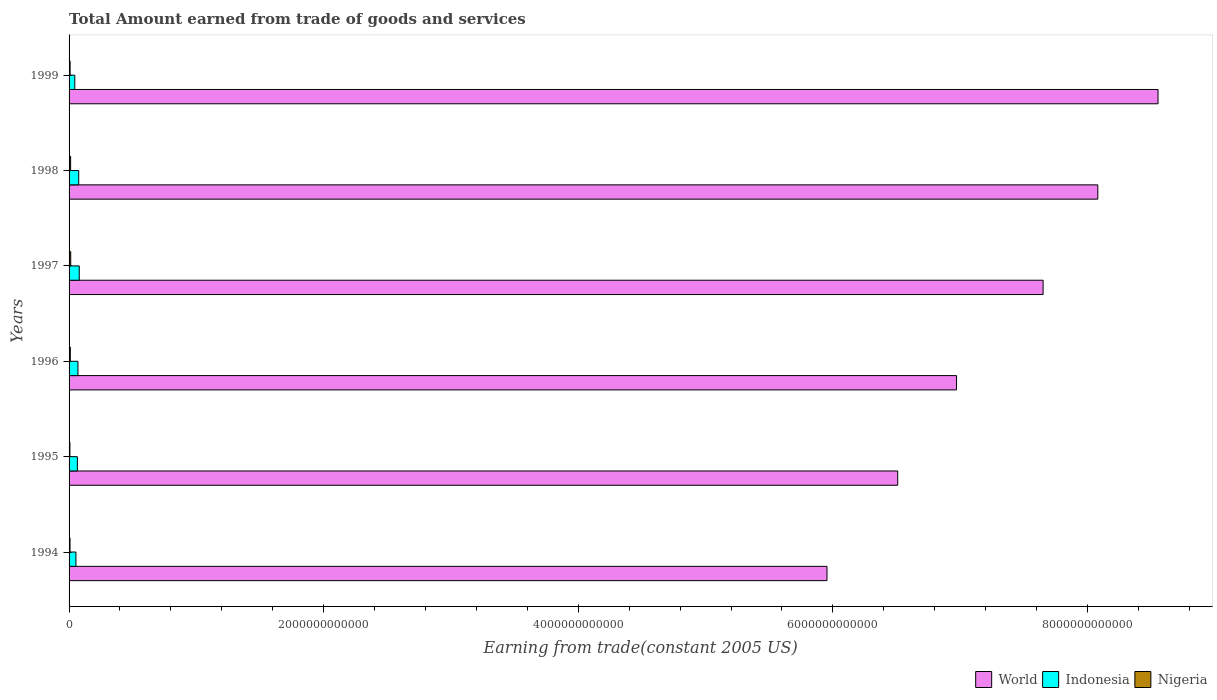How many different coloured bars are there?
Your answer should be compact. 3. How many groups of bars are there?
Offer a terse response. 6. How many bars are there on the 6th tick from the top?
Your answer should be very brief. 3. How many bars are there on the 1st tick from the bottom?
Keep it short and to the point. 3. What is the total amount earned by trading goods and services in Indonesia in 1996?
Your answer should be compact. 6.97e+1. Across all years, what is the maximum total amount earned by trading goods and services in World?
Provide a short and direct response. 8.55e+12. Across all years, what is the minimum total amount earned by trading goods and services in Nigeria?
Give a very brief answer. 6.54e+09. In which year was the total amount earned by trading goods and services in World maximum?
Provide a short and direct response. 1999. In which year was the total amount earned by trading goods and services in Nigeria minimum?
Keep it short and to the point. 1995. What is the total total amount earned by trading goods and services in Indonesia in the graph?
Give a very brief answer. 3.90e+11. What is the difference between the total amount earned by trading goods and services in Indonesia in 1995 and that in 1997?
Keep it short and to the point. -1.47e+1. What is the difference between the total amount earned by trading goods and services in World in 1995 and the total amount earned by trading goods and services in Nigeria in 1999?
Keep it short and to the point. 6.50e+12. What is the average total amount earned by trading goods and services in Indonesia per year?
Your answer should be compact. 6.49e+1. In the year 1996, what is the difference between the total amount earned by trading goods and services in Indonesia and total amount earned by trading goods and services in World?
Offer a very short reply. -6.90e+12. What is the ratio of the total amount earned by trading goods and services in World in 1998 to that in 1999?
Offer a terse response. 0.94. Is the total amount earned by trading goods and services in World in 1994 less than that in 1999?
Offer a terse response. Yes. Is the difference between the total amount earned by trading goods and services in Indonesia in 1996 and 1997 greater than the difference between the total amount earned by trading goods and services in World in 1996 and 1997?
Provide a short and direct response. Yes. What is the difference between the highest and the second highest total amount earned by trading goods and services in World?
Keep it short and to the point. 4.73e+11. What is the difference between the highest and the lowest total amount earned by trading goods and services in Indonesia?
Give a very brief answer. 3.50e+1. In how many years, is the total amount earned by trading goods and services in Indonesia greater than the average total amount earned by trading goods and services in Indonesia taken over all years?
Give a very brief answer. 4. Is the sum of the total amount earned by trading goods and services in Indonesia in 1995 and 1996 greater than the maximum total amount earned by trading goods and services in World across all years?
Your response must be concise. No. What does the 2nd bar from the top in 1995 represents?
Ensure brevity in your answer.  Indonesia. What does the 1st bar from the bottom in 1994 represents?
Give a very brief answer. World. How many bars are there?
Offer a terse response. 18. What is the difference between two consecutive major ticks on the X-axis?
Offer a terse response. 2.00e+12. Are the values on the major ticks of X-axis written in scientific E-notation?
Make the answer very short. No. Does the graph contain any zero values?
Make the answer very short. No. Does the graph contain grids?
Provide a short and direct response. No. How many legend labels are there?
Your answer should be compact. 3. What is the title of the graph?
Offer a terse response. Total Amount earned from trade of goods and services. Does "Rwanda" appear as one of the legend labels in the graph?
Your answer should be compact. No. What is the label or title of the X-axis?
Your answer should be very brief. Earning from trade(constant 2005 US). What is the Earning from trade(constant 2005 US) in World in 1994?
Give a very brief answer. 5.95e+12. What is the Earning from trade(constant 2005 US) in Indonesia in 1994?
Give a very brief answer. 5.40e+1. What is the Earning from trade(constant 2005 US) in Nigeria in 1994?
Provide a short and direct response. 7.42e+09. What is the Earning from trade(constant 2005 US) in World in 1995?
Provide a succinct answer. 6.51e+12. What is the Earning from trade(constant 2005 US) of Indonesia in 1995?
Provide a succinct answer. 6.53e+1. What is the Earning from trade(constant 2005 US) in Nigeria in 1995?
Your answer should be compact. 6.54e+09. What is the Earning from trade(constant 2005 US) in World in 1996?
Provide a succinct answer. 6.97e+12. What is the Earning from trade(constant 2005 US) of Indonesia in 1996?
Give a very brief answer. 6.97e+1. What is the Earning from trade(constant 2005 US) in Nigeria in 1996?
Offer a terse response. 9.72e+09. What is the Earning from trade(constant 2005 US) of World in 1997?
Give a very brief answer. 7.65e+12. What is the Earning from trade(constant 2005 US) in Indonesia in 1997?
Your answer should be compact. 8.00e+1. What is the Earning from trade(constant 2005 US) in Nigeria in 1997?
Keep it short and to the point. 1.31e+1. What is the Earning from trade(constant 2005 US) of World in 1998?
Ensure brevity in your answer.  8.08e+12. What is the Earning from trade(constant 2005 US) in Indonesia in 1998?
Offer a very short reply. 7.58e+1. What is the Earning from trade(constant 2005 US) in Nigeria in 1998?
Provide a short and direct response. 1.23e+1. What is the Earning from trade(constant 2005 US) in World in 1999?
Your answer should be compact. 8.55e+12. What is the Earning from trade(constant 2005 US) of Indonesia in 1999?
Your answer should be compact. 4.49e+1. What is the Earning from trade(constant 2005 US) in Nigeria in 1999?
Your answer should be very brief. 8.12e+09. Across all years, what is the maximum Earning from trade(constant 2005 US) of World?
Keep it short and to the point. 8.55e+12. Across all years, what is the maximum Earning from trade(constant 2005 US) of Indonesia?
Your answer should be compact. 8.00e+1. Across all years, what is the maximum Earning from trade(constant 2005 US) in Nigeria?
Ensure brevity in your answer.  1.31e+1. Across all years, what is the minimum Earning from trade(constant 2005 US) in World?
Provide a short and direct response. 5.95e+12. Across all years, what is the minimum Earning from trade(constant 2005 US) in Indonesia?
Give a very brief answer. 4.49e+1. Across all years, what is the minimum Earning from trade(constant 2005 US) in Nigeria?
Offer a very short reply. 6.54e+09. What is the total Earning from trade(constant 2005 US) in World in the graph?
Make the answer very short. 4.37e+13. What is the total Earning from trade(constant 2005 US) of Indonesia in the graph?
Your response must be concise. 3.90e+11. What is the total Earning from trade(constant 2005 US) of Nigeria in the graph?
Offer a terse response. 5.72e+1. What is the difference between the Earning from trade(constant 2005 US) in World in 1994 and that in 1995?
Provide a succinct answer. -5.55e+11. What is the difference between the Earning from trade(constant 2005 US) of Indonesia in 1994 and that in 1995?
Give a very brief answer. -1.13e+1. What is the difference between the Earning from trade(constant 2005 US) in Nigeria in 1994 and that in 1995?
Keep it short and to the point. 8.81e+08. What is the difference between the Earning from trade(constant 2005 US) in World in 1994 and that in 1996?
Your answer should be compact. -1.02e+12. What is the difference between the Earning from trade(constant 2005 US) of Indonesia in 1994 and that in 1996?
Your response must be concise. -1.58e+1. What is the difference between the Earning from trade(constant 2005 US) of Nigeria in 1994 and that in 1996?
Give a very brief answer. -2.31e+09. What is the difference between the Earning from trade(constant 2005 US) of World in 1994 and that in 1997?
Provide a succinct answer. -1.70e+12. What is the difference between the Earning from trade(constant 2005 US) of Indonesia in 1994 and that in 1997?
Offer a terse response. -2.60e+1. What is the difference between the Earning from trade(constant 2005 US) of Nigeria in 1994 and that in 1997?
Offer a very short reply. -5.70e+09. What is the difference between the Earning from trade(constant 2005 US) in World in 1994 and that in 1998?
Make the answer very short. -2.13e+12. What is the difference between the Earning from trade(constant 2005 US) of Indonesia in 1994 and that in 1998?
Ensure brevity in your answer.  -2.18e+1. What is the difference between the Earning from trade(constant 2005 US) in Nigeria in 1994 and that in 1998?
Offer a very short reply. -4.84e+09. What is the difference between the Earning from trade(constant 2005 US) in World in 1994 and that in 1999?
Make the answer very short. -2.60e+12. What is the difference between the Earning from trade(constant 2005 US) of Indonesia in 1994 and that in 1999?
Provide a short and direct response. 9.01e+09. What is the difference between the Earning from trade(constant 2005 US) of Nigeria in 1994 and that in 1999?
Keep it short and to the point. -7.09e+08. What is the difference between the Earning from trade(constant 2005 US) of World in 1995 and that in 1996?
Make the answer very short. -4.62e+11. What is the difference between the Earning from trade(constant 2005 US) in Indonesia in 1995 and that in 1996?
Your answer should be compact. -4.48e+09. What is the difference between the Earning from trade(constant 2005 US) of Nigeria in 1995 and that in 1996?
Make the answer very short. -3.19e+09. What is the difference between the Earning from trade(constant 2005 US) in World in 1995 and that in 1997?
Your response must be concise. -1.14e+12. What is the difference between the Earning from trade(constant 2005 US) in Indonesia in 1995 and that in 1997?
Make the answer very short. -1.47e+1. What is the difference between the Earning from trade(constant 2005 US) of Nigeria in 1995 and that in 1997?
Provide a succinct answer. -6.58e+09. What is the difference between the Earning from trade(constant 2005 US) in World in 1995 and that in 1998?
Offer a very short reply. -1.57e+12. What is the difference between the Earning from trade(constant 2005 US) of Indonesia in 1995 and that in 1998?
Offer a very short reply. -1.05e+1. What is the difference between the Earning from trade(constant 2005 US) in Nigeria in 1995 and that in 1998?
Your answer should be very brief. -5.72e+09. What is the difference between the Earning from trade(constant 2005 US) of World in 1995 and that in 1999?
Offer a terse response. -2.05e+12. What is the difference between the Earning from trade(constant 2005 US) of Indonesia in 1995 and that in 1999?
Your answer should be very brief. 2.03e+1. What is the difference between the Earning from trade(constant 2005 US) in Nigeria in 1995 and that in 1999?
Provide a short and direct response. -1.59e+09. What is the difference between the Earning from trade(constant 2005 US) of World in 1996 and that in 1997?
Provide a succinct answer. -6.80e+11. What is the difference between the Earning from trade(constant 2005 US) in Indonesia in 1996 and that in 1997?
Your answer should be very brief. -1.03e+1. What is the difference between the Earning from trade(constant 2005 US) of Nigeria in 1996 and that in 1997?
Give a very brief answer. -3.39e+09. What is the difference between the Earning from trade(constant 2005 US) in World in 1996 and that in 1998?
Ensure brevity in your answer.  -1.11e+12. What is the difference between the Earning from trade(constant 2005 US) of Indonesia in 1996 and that in 1998?
Your response must be concise. -6.03e+09. What is the difference between the Earning from trade(constant 2005 US) of Nigeria in 1996 and that in 1998?
Your response must be concise. -2.53e+09. What is the difference between the Earning from trade(constant 2005 US) of World in 1996 and that in 1999?
Your response must be concise. -1.58e+12. What is the difference between the Earning from trade(constant 2005 US) in Indonesia in 1996 and that in 1999?
Keep it short and to the point. 2.48e+1. What is the difference between the Earning from trade(constant 2005 US) in Nigeria in 1996 and that in 1999?
Provide a succinct answer. 1.60e+09. What is the difference between the Earning from trade(constant 2005 US) in World in 1997 and that in 1998?
Your answer should be compact. -4.30e+11. What is the difference between the Earning from trade(constant 2005 US) of Indonesia in 1997 and that in 1998?
Make the answer very short. 4.23e+09. What is the difference between the Earning from trade(constant 2005 US) of Nigeria in 1997 and that in 1998?
Provide a short and direct response. 8.57e+08. What is the difference between the Earning from trade(constant 2005 US) of World in 1997 and that in 1999?
Offer a terse response. -9.03e+11. What is the difference between the Earning from trade(constant 2005 US) in Indonesia in 1997 and that in 1999?
Provide a short and direct response. 3.50e+1. What is the difference between the Earning from trade(constant 2005 US) in Nigeria in 1997 and that in 1999?
Your response must be concise. 4.99e+09. What is the difference between the Earning from trade(constant 2005 US) of World in 1998 and that in 1999?
Give a very brief answer. -4.73e+11. What is the difference between the Earning from trade(constant 2005 US) of Indonesia in 1998 and that in 1999?
Your answer should be compact. 3.08e+1. What is the difference between the Earning from trade(constant 2005 US) in Nigeria in 1998 and that in 1999?
Make the answer very short. 4.13e+09. What is the difference between the Earning from trade(constant 2005 US) in World in 1994 and the Earning from trade(constant 2005 US) in Indonesia in 1995?
Provide a succinct answer. 5.89e+12. What is the difference between the Earning from trade(constant 2005 US) in World in 1994 and the Earning from trade(constant 2005 US) in Nigeria in 1995?
Provide a succinct answer. 5.95e+12. What is the difference between the Earning from trade(constant 2005 US) in Indonesia in 1994 and the Earning from trade(constant 2005 US) in Nigeria in 1995?
Make the answer very short. 4.74e+1. What is the difference between the Earning from trade(constant 2005 US) in World in 1994 and the Earning from trade(constant 2005 US) in Indonesia in 1996?
Your answer should be very brief. 5.88e+12. What is the difference between the Earning from trade(constant 2005 US) in World in 1994 and the Earning from trade(constant 2005 US) in Nigeria in 1996?
Make the answer very short. 5.94e+12. What is the difference between the Earning from trade(constant 2005 US) in Indonesia in 1994 and the Earning from trade(constant 2005 US) in Nigeria in 1996?
Your answer should be very brief. 4.42e+1. What is the difference between the Earning from trade(constant 2005 US) in World in 1994 and the Earning from trade(constant 2005 US) in Indonesia in 1997?
Your answer should be compact. 5.87e+12. What is the difference between the Earning from trade(constant 2005 US) of World in 1994 and the Earning from trade(constant 2005 US) of Nigeria in 1997?
Ensure brevity in your answer.  5.94e+12. What is the difference between the Earning from trade(constant 2005 US) of Indonesia in 1994 and the Earning from trade(constant 2005 US) of Nigeria in 1997?
Your response must be concise. 4.08e+1. What is the difference between the Earning from trade(constant 2005 US) in World in 1994 and the Earning from trade(constant 2005 US) in Indonesia in 1998?
Offer a very short reply. 5.88e+12. What is the difference between the Earning from trade(constant 2005 US) in World in 1994 and the Earning from trade(constant 2005 US) in Nigeria in 1998?
Provide a short and direct response. 5.94e+12. What is the difference between the Earning from trade(constant 2005 US) in Indonesia in 1994 and the Earning from trade(constant 2005 US) in Nigeria in 1998?
Make the answer very short. 4.17e+1. What is the difference between the Earning from trade(constant 2005 US) in World in 1994 and the Earning from trade(constant 2005 US) in Indonesia in 1999?
Your answer should be compact. 5.91e+12. What is the difference between the Earning from trade(constant 2005 US) in World in 1994 and the Earning from trade(constant 2005 US) in Nigeria in 1999?
Your answer should be compact. 5.95e+12. What is the difference between the Earning from trade(constant 2005 US) of Indonesia in 1994 and the Earning from trade(constant 2005 US) of Nigeria in 1999?
Your response must be concise. 4.58e+1. What is the difference between the Earning from trade(constant 2005 US) of World in 1995 and the Earning from trade(constant 2005 US) of Indonesia in 1996?
Offer a terse response. 6.44e+12. What is the difference between the Earning from trade(constant 2005 US) of World in 1995 and the Earning from trade(constant 2005 US) of Nigeria in 1996?
Keep it short and to the point. 6.50e+12. What is the difference between the Earning from trade(constant 2005 US) in Indonesia in 1995 and the Earning from trade(constant 2005 US) in Nigeria in 1996?
Offer a very short reply. 5.55e+1. What is the difference between the Earning from trade(constant 2005 US) in World in 1995 and the Earning from trade(constant 2005 US) in Indonesia in 1997?
Give a very brief answer. 6.43e+12. What is the difference between the Earning from trade(constant 2005 US) of World in 1995 and the Earning from trade(constant 2005 US) of Nigeria in 1997?
Offer a very short reply. 6.50e+12. What is the difference between the Earning from trade(constant 2005 US) of Indonesia in 1995 and the Earning from trade(constant 2005 US) of Nigeria in 1997?
Ensure brevity in your answer.  5.21e+1. What is the difference between the Earning from trade(constant 2005 US) in World in 1995 and the Earning from trade(constant 2005 US) in Indonesia in 1998?
Your answer should be very brief. 6.43e+12. What is the difference between the Earning from trade(constant 2005 US) in World in 1995 and the Earning from trade(constant 2005 US) in Nigeria in 1998?
Keep it short and to the point. 6.50e+12. What is the difference between the Earning from trade(constant 2005 US) in Indonesia in 1995 and the Earning from trade(constant 2005 US) in Nigeria in 1998?
Offer a very short reply. 5.30e+1. What is the difference between the Earning from trade(constant 2005 US) of World in 1995 and the Earning from trade(constant 2005 US) of Indonesia in 1999?
Give a very brief answer. 6.46e+12. What is the difference between the Earning from trade(constant 2005 US) in World in 1995 and the Earning from trade(constant 2005 US) in Nigeria in 1999?
Provide a succinct answer. 6.50e+12. What is the difference between the Earning from trade(constant 2005 US) of Indonesia in 1995 and the Earning from trade(constant 2005 US) of Nigeria in 1999?
Ensure brevity in your answer.  5.71e+1. What is the difference between the Earning from trade(constant 2005 US) in World in 1996 and the Earning from trade(constant 2005 US) in Indonesia in 1997?
Keep it short and to the point. 6.89e+12. What is the difference between the Earning from trade(constant 2005 US) in World in 1996 and the Earning from trade(constant 2005 US) in Nigeria in 1997?
Provide a succinct answer. 6.96e+12. What is the difference between the Earning from trade(constant 2005 US) of Indonesia in 1996 and the Earning from trade(constant 2005 US) of Nigeria in 1997?
Your response must be concise. 5.66e+1. What is the difference between the Earning from trade(constant 2005 US) in World in 1996 and the Earning from trade(constant 2005 US) in Indonesia in 1998?
Provide a short and direct response. 6.90e+12. What is the difference between the Earning from trade(constant 2005 US) of World in 1996 and the Earning from trade(constant 2005 US) of Nigeria in 1998?
Provide a succinct answer. 6.96e+12. What is the difference between the Earning from trade(constant 2005 US) in Indonesia in 1996 and the Earning from trade(constant 2005 US) in Nigeria in 1998?
Keep it short and to the point. 5.75e+1. What is the difference between the Earning from trade(constant 2005 US) of World in 1996 and the Earning from trade(constant 2005 US) of Indonesia in 1999?
Your answer should be very brief. 6.93e+12. What is the difference between the Earning from trade(constant 2005 US) in World in 1996 and the Earning from trade(constant 2005 US) in Nigeria in 1999?
Offer a terse response. 6.96e+12. What is the difference between the Earning from trade(constant 2005 US) of Indonesia in 1996 and the Earning from trade(constant 2005 US) of Nigeria in 1999?
Ensure brevity in your answer.  6.16e+1. What is the difference between the Earning from trade(constant 2005 US) of World in 1997 and the Earning from trade(constant 2005 US) of Indonesia in 1998?
Your answer should be compact. 7.58e+12. What is the difference between the Earning from trade(constant 2005 US) in World in 1997 and the Earning from trade(constant 2005 US) in Nigeria in 1998?
Offer a very short reply. 7.64e+12. What is the difference between the Earning from trade(constant 2005 US) of Indonesia in 1997 and the Earning from trade(constant 2005 US) of Nigeria in 1998?
Provide a short and direct response. 6.77e+1. What is the difference between the Earning from trade(constant 2005 US) of World in 1997 and the Earning from trade(constant 2005 US) of Indonesia in 1999?
Offer a very short reply. 7.61e+12. What is the difference between the Earning from trade(constant 2005 US) of World in 1997 and the Earning from trade(constant 2005 US) of Nigeria in 1999?
Keep it short and to the point. 7.64e+12. What is the difference between the Earning from trade(constant 2005 US) of Indonesia in 1997 and the Earning from trade(constant 2005 US) of Nigeria in 1999?
Offer a terse response. 7.19e+1. What is the difference between the Earning from trade(constant 2005 US) in World in 1998 and the Earning from trade(constant 2005 US) in Indonesia in 1999?
Your answer should be very brief. 8.04e+12. What is the difference between the Earning from trade(constant 2005 US) of World in 1998 and the Earning from trade(constant 2005 US) of Nigeria in 1999?
Your answer should be compact. 8.07e+12. What is the difference between the Earning from trade(constant 2005 US) of Indonesia in 1998 and the Earning from trade(constant 2005 US) of Nigeria in 1999?
Ensure brevity in your answer.  6.76e+1. What is the average Earning from trade(constant 2005 US) in World per year?
Keep it short and to the point. 7.29e+12. What is the average Earning from trade(constant 2005 US) of Indonesia per year?
Provide a succinct answer. 6.49e+1. What is the average Earning from trade(constant 2005 US) of Nigeria per year?
Your response must be concise. 9.53e+09. In the year 1994, what is the difference between the Earning from trade(constant 2005 US) of World and Earning from trade(constant 2005 US) of Indonesia?
Provide a short and direct response. 5.90e+12. In the year 1994, what is the difference between the Earning from trade(constant 2005 US) of World and Earning from trade(constant 2005 US) of Nigeria?
Keep it short and to the point. 5.95e+12. In the year 1994, what is the difference between the Earning from trade(constant 2005 US) in Indonesia and Earning from trade(constant 2005 US) in Nigeria?
Provide a succinct answer. 4.65e+1. In the year 1995, what is the difference between the Earning from trade(constant 2005 US) of World and Earning from trade(constant 2005 US) of Indonesia?
Your response must be concise. 6.44e+12. In the year 1995, what is the difference between the Earning from trade(constant 2005 US) in World and Earning from trade(constant 2005 US) in Nigeria?
Keep it short and to the point. 6.50e+12. In the year 1995, what is the difference between the Earning from trade(constant 2005 US) of Indonesia and Earning from trade(constant 2005 US) of Nigeria?
Offer a very short reply. 5.87e+1. In the year 1996, what is the difference between the Earning from trade(constant 2005 US) in World and Earning from trade(constant 2005 US) in Indonesia?
Offer a terse response. 6.90e+12. In the year 1996, what is the difference between the Earning from trade(constant 2005 US) in World and Earning from trade(constant 2005 US) in Nigeria?
Provide a succinct answer. 6.96e+12. In the year 1996, what is the difference between the Earning from trade(constant 2005 US) of Indonesia and Earning from trade(constant 2005 US) of Nigeria?
Your response must be concise. 6.00e+1. In the year 1997, what is the difference between the Earning from trade(constant 2005 US) in World and Earning from trade(constant 2005 US) in Indonesia?
Keep it short and to the point. 7.57e+12. In the year 1997, what is the difference between the Earning from trade(constant 2005 US) in World and Earning from trade(constant 2005 US) in Nigeria?
Your answer should be compact. 7.64e+12. In the year 1997, what is the difference between the Earning from trade(constant 2005 US) of Indonesia and Earning from trade(constant 2005 US) of Nigeria?
Provide a short and direct response. 6.69e+1. In the year 1998, what is the difference between the Earning from trade(constant 2005 US) in World and Earning from trade(constant 2005 US) in Indonesia?
Keep it short and to the point. 8.01e+12. In the year 1998, what is the difference between the Earning from trade(constant 2005 US) in World and Earning from trade(constant 2005 US) in Nigeria?
Give a very brief answer. 8.07e+12. In the year 1998, what is the difference between the Earning from trade(constant 2005 US) of Indonesia and Earning from trade(constant 2005 US) of Nigeria?
Your answer should be compact. 6.35e+1. In the year 1999, what is the difference between the Earning from trade(constant 2005 US) in World and Earning from trade(constant 2005 US) in Indonesia?
Give a very brief answer. 8.51e+12. In the year 1999, what is the difference between the Earning from trade(constant 2005 US) of World and Earning from trade(constant 2005 US) of Nigeria?
Give a very brief answer. 8.55e+12. In the year 1999, what is the difference between the Earning from trade(constant 2005 US) in Indonesia and Earning from trade(constant 2005 US) in Nigeria?
Your answer should be compact. 3.68e+1. What is the ratio of the Earning from trade(constant 2005 US) in World in 1994 to that in 1995?
Ensure brevity in your answer.  0.91. What is the ratio of the Earning from trade(constant 2005 US) of Indonesia in 1994 to that in 1995?
Ensure brevity in your answer.  0.83. What is the ratio of the Earning from trade(constant 2005 US) in Nigeria in 1994 to that in 1995?
Your answer should be very brief. 1.13. What is the ratio of the Earning from trade(constant 2005 US) in World in 1994 to that in 1996?
Your answer should be compact. 0.85. What is the ratio of the Earning from trade(constant 2005 US) of Indonesia in 1994 to that in 1996?
Give a very brief answer. 0.77. What is the ratio of the Earning from trade(constant 2005 US) in Nigeria in 1994 to that in 1996?
Provide a short and direct response. 0.76. What is the ratio of the Earning from trade(constant 2005 US) in World in 1994 to that in 1997?
Provide a succinct answer. 0.78. What is the ratio of the Earning from trade(constant 2005 US) in Indonesia in 1994 to that in 1997?
Offer a terse response. 0.67. What is the ratio of the Earning from trade(constant 2005 US) in Nigeria in 1994 to that in 1997?
Provide a succinct answer. 0.57. What is the ratio of the Earning from trade(constant 2005 US) of World in 1994 to that in 1998?
Keep it short and to the point. 0.74. What is the ratio of the Earning from trade(constant 2005 US) of Indonesia in 1994 to that in 1998?
Make the answer very short. 0.71. What is the ratio of the Earning from trade(constant 2005 US) of Nigeria in 1994 to that in 1998?
Your answer should be compact. 0.61. What is the ratio of the Earning from trade(constant 2005 US) in World in 1994 to that in 1999?
Your answer should be compact. 0.7. What is the ratio of the Earning from trade(constant 2005 US) in Indonesia in 1994 to that in 1999?
Provide a succinct answer. 1.2. What is the ratio of the Earning from trade(constant 2005 US) in Nigeria in 1994 to that in 1999?
Provide a short and direct response. 0.91. What is the ratio of the Earning from trade(constant 2005 US) in World in 1995 to that in 1996?
Provide a succinct answer. 0.93. What is the ratio of the Earning from trade(constant 2005 US) in Indonesia in 1995 to that in 1996?
Your answer should be very brief. 0.94. What is the ratio of the Earning from trade(constant 2005 US) of Nigeria in 1995 to that in 1996?
Offer a terse response. 0.67. What is the ratio of the Earning from trade(constant 2005 US) of World in 1995 to that in 1997?
Give a very brief answer. 0.85. What is the ratio of the Earning from trade(constant 2005 US) in Indonesia in 1995 to that in 1997?
Give a very brief answer. 0.82. What is the ratio of the Earning from trade(constant 2005 US) of Nigeria in 1995 to that in 1997?
Your response must be concise. 0.5. What is the ratio of the Earning from trade(constant 2005 US) of World in 1995 to that in 1998?
Make the answer very short. 0.81. What is the ratio of the Earning from trade(constant 2005 US) in Indonesia in 1995 to that in 1998?
Your answer should be very brief. 0.86. What is the ratio of the Earning from trade(constant 2005 US) of Nigeria in 1995 to that in 1998?
Make the answer very short. 0.53. What is the ratio of the Earning from trade(constant 2005 US) in World in 1995 to that in 1999?
Give a very brief answer. 0.76. What is the ratio of the Earning from trade(constant 2005 US) of Indonesia in 1995 to that in 1999?
Your response must be concise. 1.45. What is the ratio of the Earning from trade(constant 2005 US) of Nigeria in 1995 to that in 1999?
Offer a very short reply. 0.8. What is the ratio of the Earning from trade(constant 2005 US) in World in 1996 to that in 1997?
Provide a succinct answer. 0.91. What is the ratio of the Earning from trade(constant 2005 US) of Indonesia in 1996 to that in 1997?
Your answer should be very brief. 0.87. What is the ratio of the Earning from trade(constant 2005 US) in Nigeria in 1996 to that in 1997?
Provide a succinct answer. 0.74. What is the ratio of the Earning from trade(constant 2005 US) in World in 1996 to that in 1998?
Offer a very short reply. 0.86. What is the ratio of the Earning from trade(constant 2005 US) of Indonesia in 1996 to that in 1998?
Your answer should be compact. 0.92. What is the ratio of the Earning from trade(constant 2005 US) of Nigeria in 1996 to that in 1998?
Your answer should be compact. 0.79. What is the ratio of the Earning from trade(constant 2005 US) of World in 1996 to that in 1999?
Ensure brevity in your answer.  0.81. What is the ratio of the Earning from trade(constant 2005 US) of Indonesia in 1996 to that in 1999?
Ensure brevity in your answer.  1.55. What is the ratio of the Earning from trade(constant 2005 US) of Nigeria in 1996 to that in 1999?
Keep it short and to the point. 1.2. What is the ratio of the Earning from trade(constant 2005 US) of World in 1997 to that in 1998?
Provide a short and direct response. 0.95. What is the ratio of the Earning from trade(constant 2005 US) in Indonesia in 1997 to that in 1998?
Your response must be concise. 1.06. What is the ratio of the Earning from trade(constant 2005 US) in Nigeria in 1997 to that in 1998?
Your answer should be very brief. 1.07. What is the ratio of the Earning from trade(constant 2005 US) of World in 1997 to that in 1999?
Keep it short and to the point. 0.89. What is the ratio of the Earning from trade(constant 2005 US) in Indonesia in 1997 to that in 1999?
Provide a succinct answer. 1.78. What is the ratio of the Earning from trade(constant 2005 US) in Nigeria in 1997 to that in 1999?
Your answer should be very brief. 1.61. What is the ratio of the Earning from trade(constant 2005 US) of World in 1998 to that in 1999?
Make the answer very short. 0.94. What is the ratio of the Earning from trade(constant 2005 US) in Indonesia in 1998 to that in 1999?
Offer a very short reply. 1.69. What is the ratio of the Earning from trade(constant 2005 US) of Nigeria in 1998 to that in 1999?
Your answer should be compact. 1.51. What is the difference between the highest and the second highest Earning from trade(constant 2005 US) of World?
Offer a terse response. 4.73e+11. What is the difference between the highest and the second highest Earning from trade(constant 2005 US) in Indonesia?
Your answer should be compact. 4.23e+09. What is the difference between the highest and the second highest Earning from trade(constant 2005 US) of Nigeria?
Ensure brevity in your answer.  8.57e+08. What is the difference between the highest and the lowest Earning from trade(constant 2005 US) in World?
Offer a very short reply. 2.60e+12. What is the difference between the highest and the lowest Earning from trade(constant 2005 US) of Indonesia?
Give a very brief answer. 3.50e+1. What is the difference between the highest and the lowest Earning from trade(constant 2005 US) in Nigeria?
Ensure brevity in your answer.  6.58e+09. 